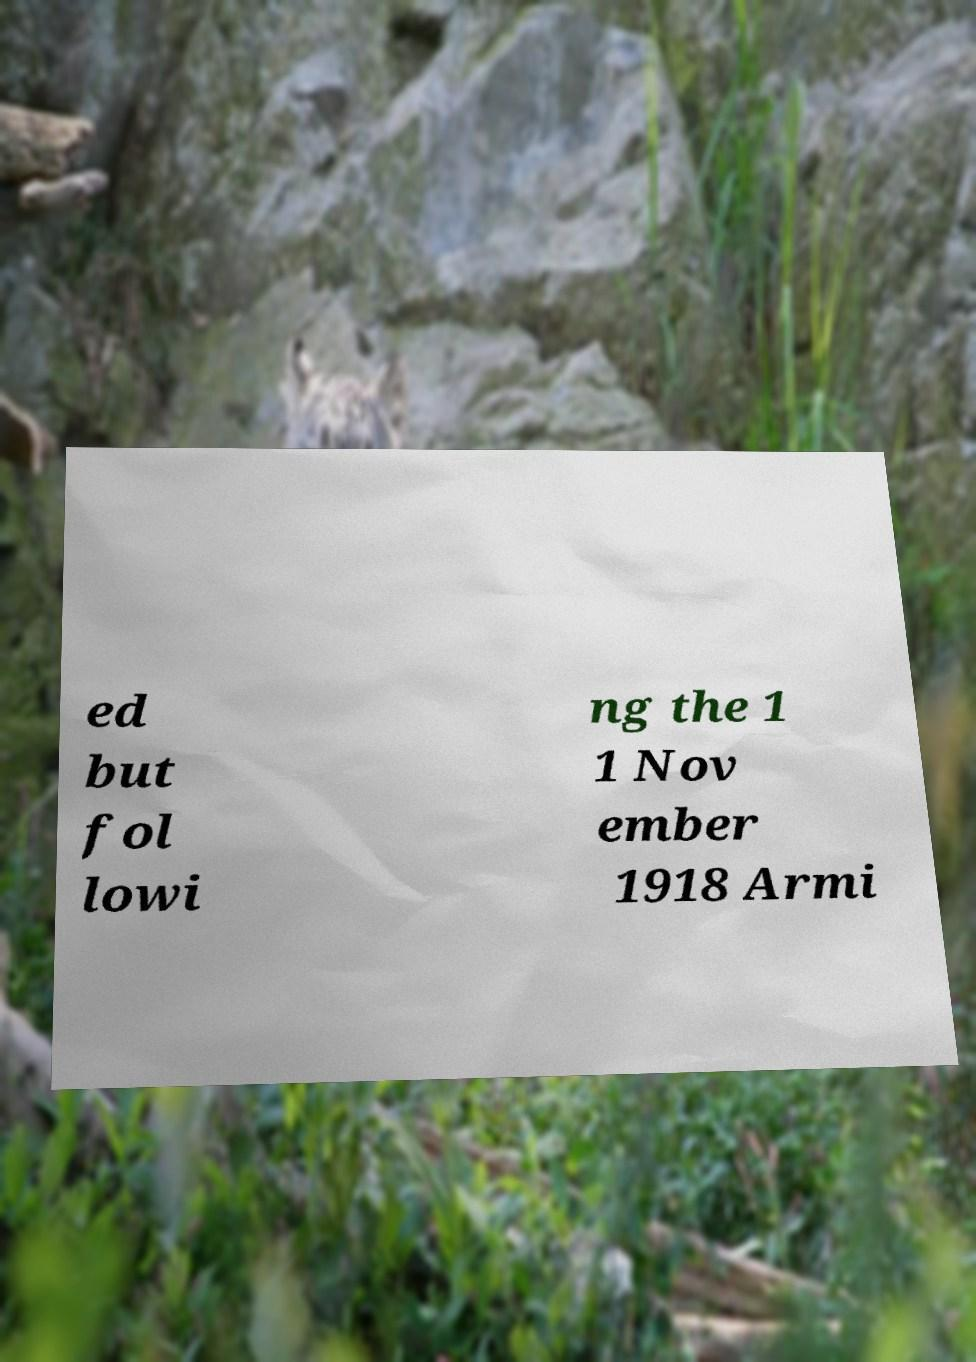Can you read and provide the text displayed in the image?This photo seems to have some interesting text. Can you extract and type it out for me? ed but fol lowi ng the 1 1 Nov ember 1918 Armi 